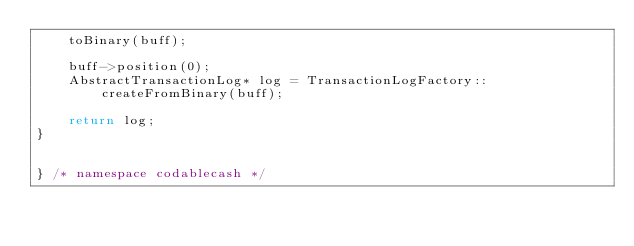<code> <loc_0><loc_0><loc_500><loc_500><_C++_>	toBinary(buff);

	buff->position(0);
	AbstractTransactionLog* log = TransactionLogFactory::createFromBinary(buff);

	return log;
}


} /* namespace codablecash */
</code> 